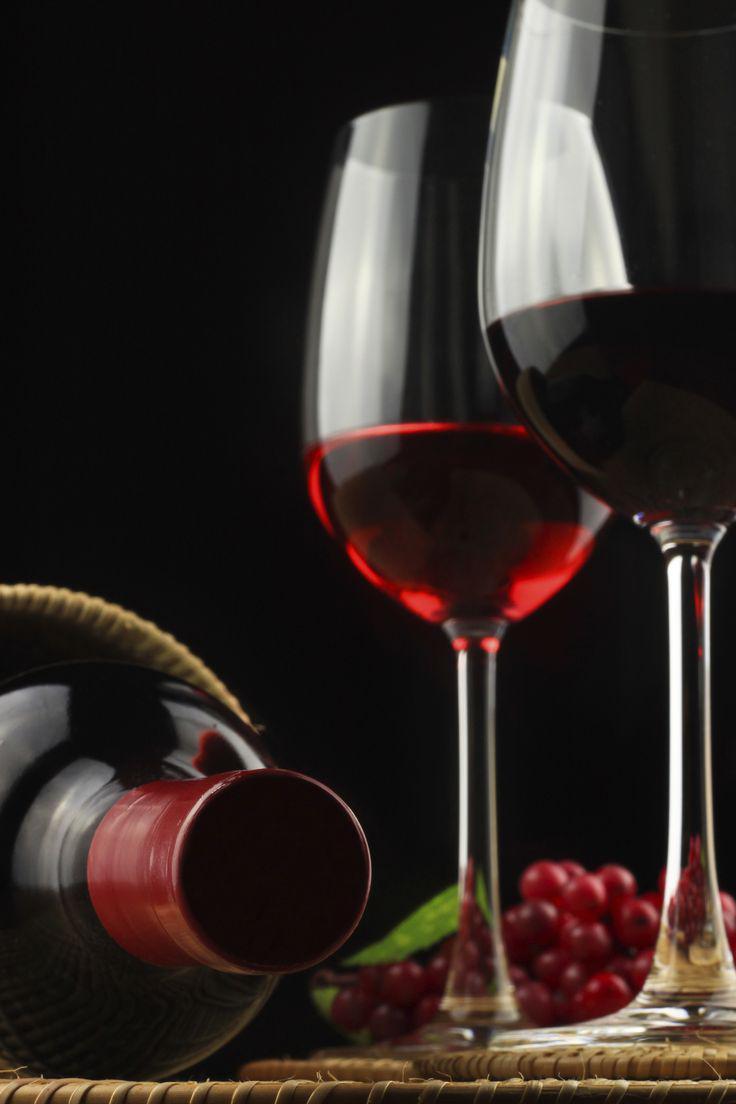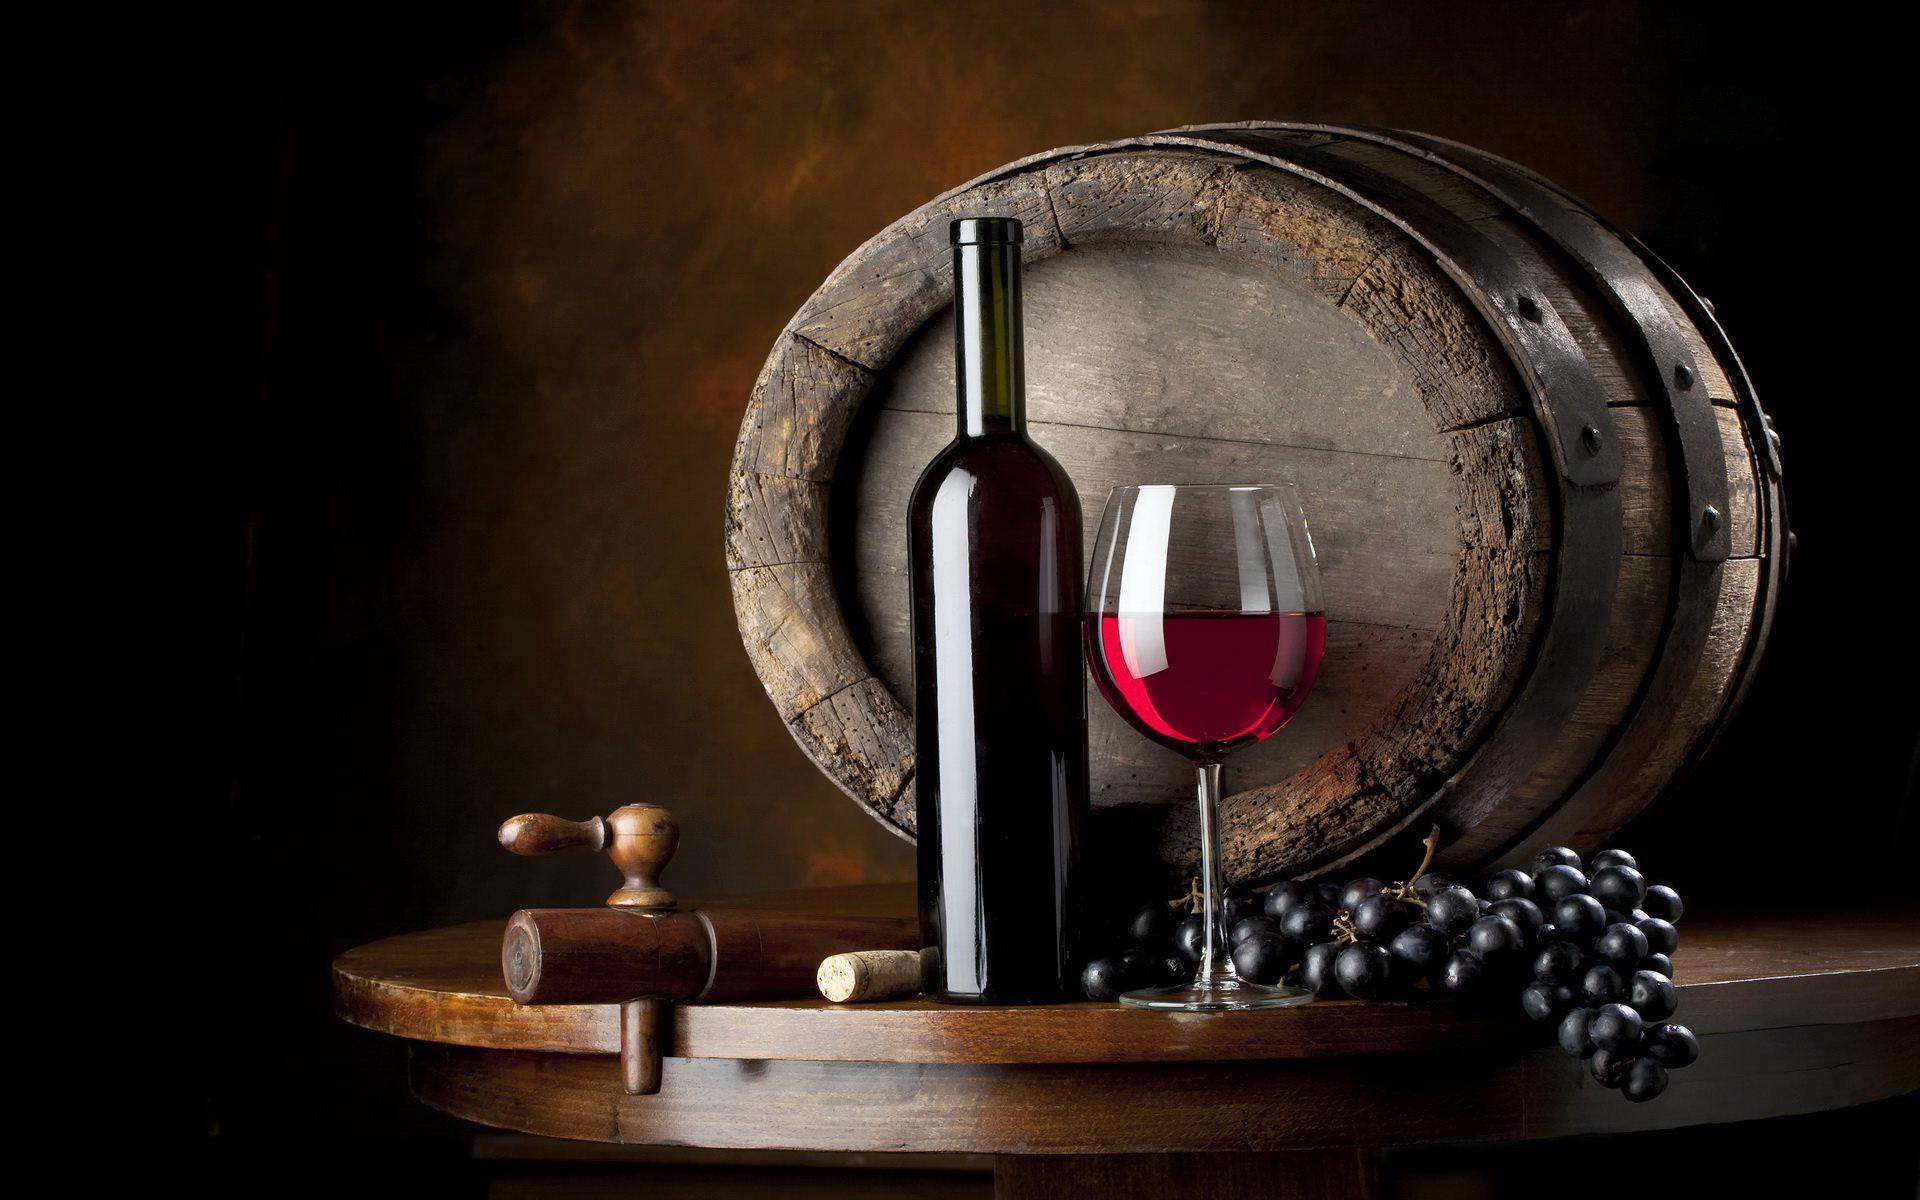The first image is the image on the left, the second image is the image on the right. Assess this claim about the two images: "There are two wineglasses in one of the images.". Correct or not? Answer yes or no. Yes. 